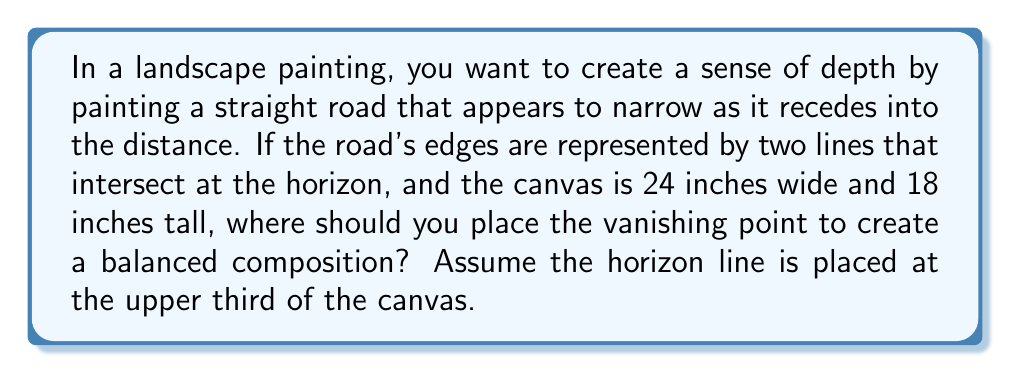Solve this math problem. Let's approach this step-by-step:

1. First, we need to determine the position of the horizon line:
   - The canvas is 18 inches tall
   - The horizon should be at the upper third
   - So, the horizon line is at: $18 \times \frac{2}{3} = 12$ inches from the bottom

2. In a balanced composition, the vanishing point is often placed using the Rule of Thirds. This means it should be either 1/3 or 2/3 of the way across the canvas horizontally.

3. To calculate these positions:
   - 1/3 of the width: $24 \times \frac{1}{3} = 8$ inches from either side
   - 2/3 of the width: $24 \times \frac{2}{3} = 16$ inches from either side

4. Now, we need to consider the perspective lines of the road:
   - These lines should converge at the vanishing point
   - For a balanced composition, these lines should create similar angles with the bottom of the canvas

5. Given the artist's perspective as a struggling female artist, we might choose the 1/3 position (8 inches from the left) for a slightly more dynamic and challenging composition.

6. The vanishing point coordinates would then be:
   - x-coordinate: 8 inches from the left
   - y-coordinate: 12 inches from the bottom

This placement will create a sense of depth while maintaining a balanced and visually interesting composition.
Answer: (8, 12) inches from the bottom-left corner of the canvas 